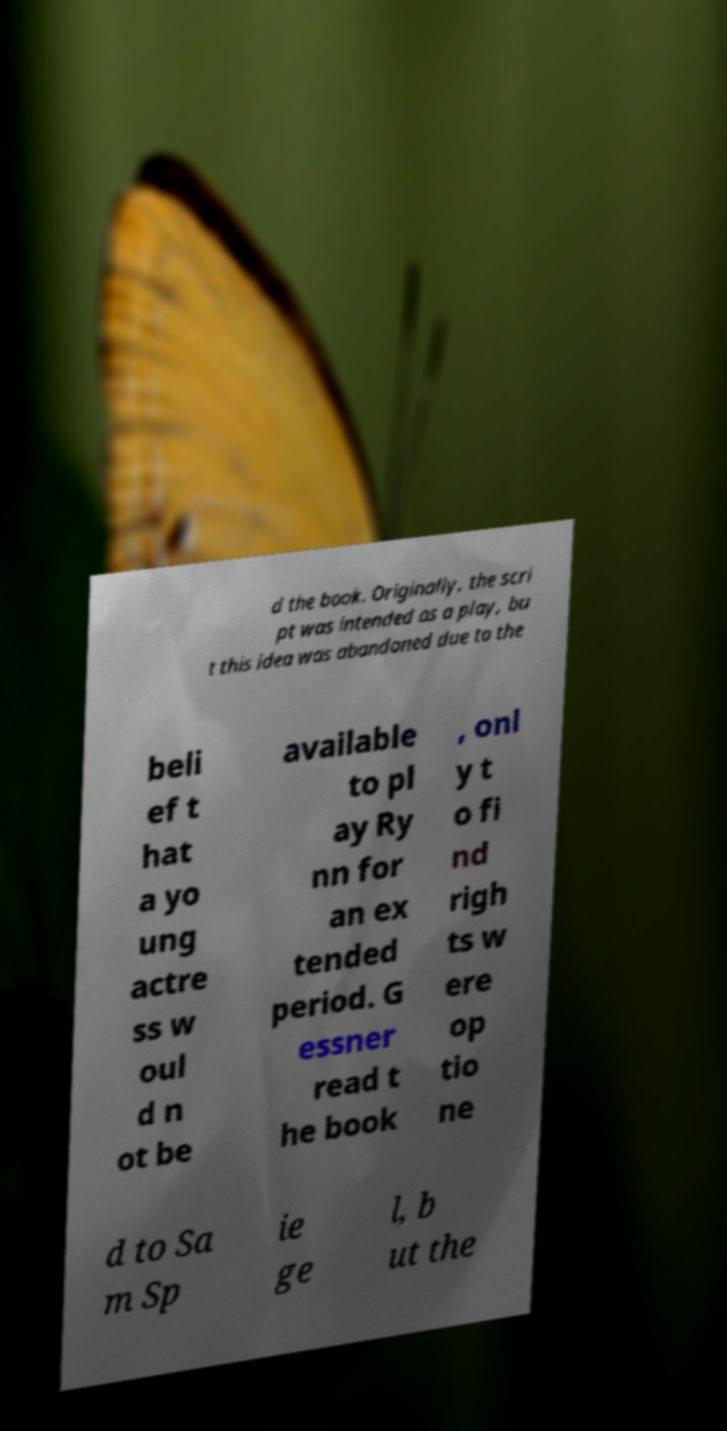Could you extract and type out the text from this image? d the book. Originally, the scri pt was intended as a play, bu t this idea was abandoned due to the beli ef t hat a yo ung actre ss w oul d n ot be available to pl ay Ry nn for an ex tended period. G essner read t he book , onl y t o fi nd righ ts w ere op tio ne d to Sa m Sp ie ge l, b ut the 